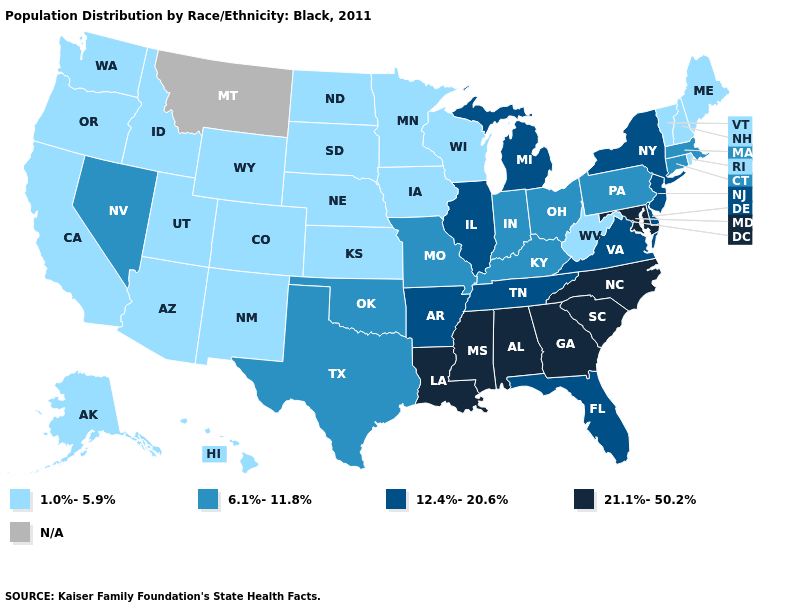How many symbols are there in the legend?
Write a very short answer. 5. What is the lowest value in the USA?
Answer briefly. 1.0%-5.9%. Among the states that border Oklahoma , which have the lowest value?
Short answer required. Colorado, Kansas, New Mexico. Is the legend a continuous bar?
Concise answer only. No. What is the lowest value in the USA?
Write a very short answer. 1.0%-5.9%. Name the states that have a value in the range 6.1%-11.8%?
Keep it brief. Connecticut, Indiana, Kentucky, Massachusetts, Missouri, Nevada, Ohio, Oklahoma, Pennsylvania, Texas. What is the highest value in the USA?
Concise answer only. 21.1%-50.2%. Among the states that border Oklahoma , does Colorado have the lowest value?
Keep it brief. Yes. What is the value of Nebraska?
Give a very brief answer. 1.0%-5.9%. What is the lowest value in the South?
Concise answer only. 1.0%-5.9%. Does the map have missing data?
Answer briefly. Yes. Does the map have missing data?
Give a very brief answer. Yes. Which states have the lowest value in the Northeast?
Quick response, please. Maine, New Hampshire, Rhode Island, Vermont. What is the lowest value in states that border Michigan?
Write a very short answer. 1.0%-5.9%. What is the lowest value in the Northeast?
Short answer required. 1.0%-5.9%. 